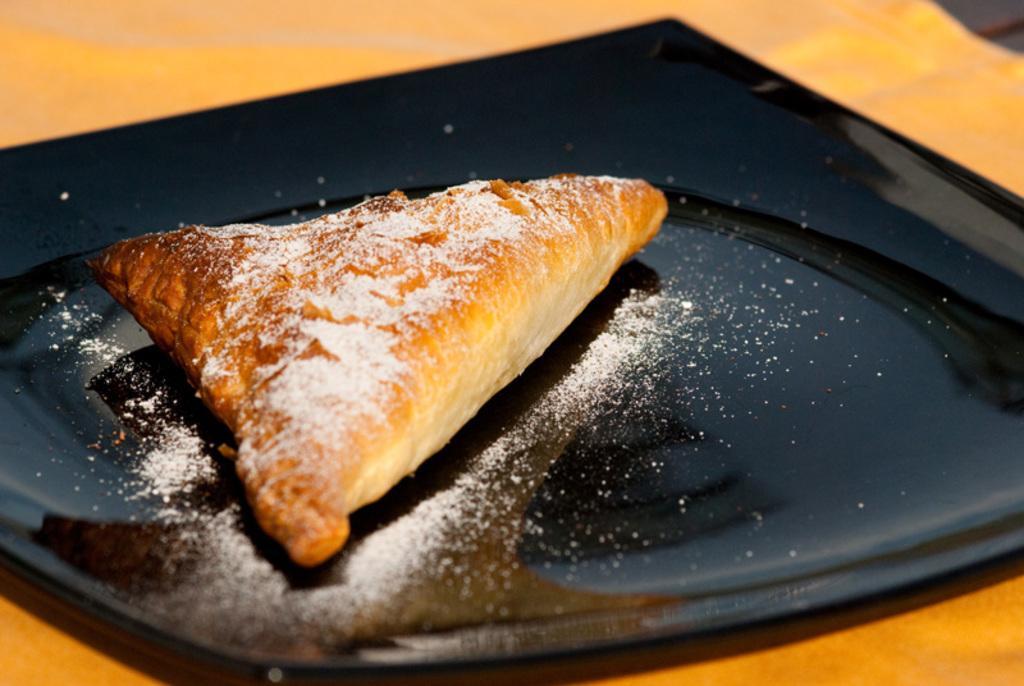Please provide a concise description of this image. In this picture we can see a food item on a black plate and this plate is on an orange surface. 